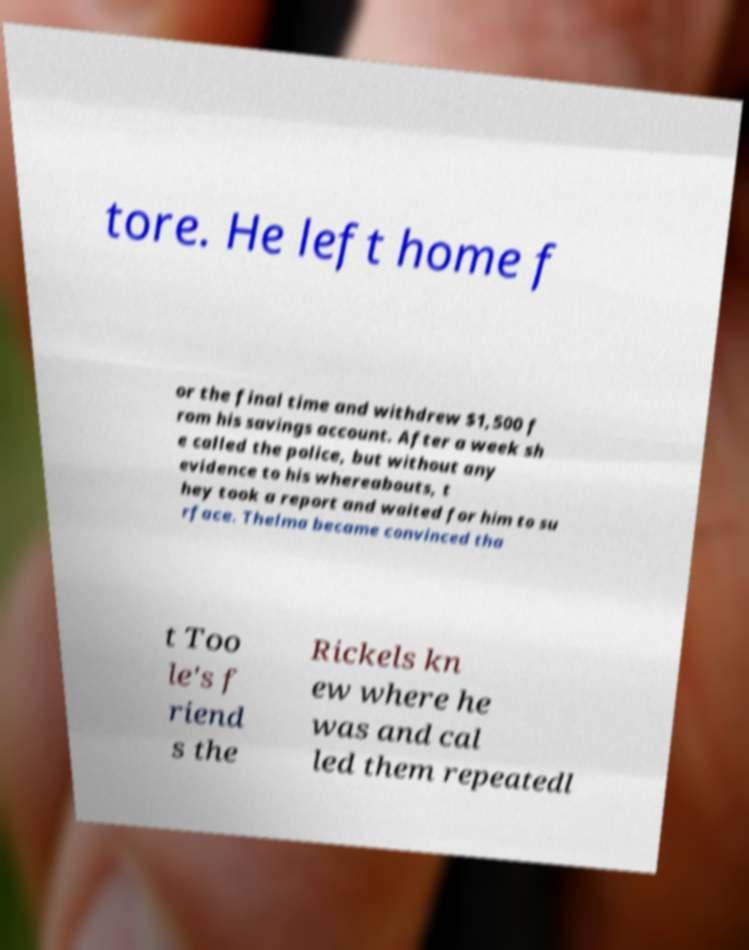Can you read and provide the text displayed in the image?This photo seems to have some interesting text. Can you extract and type it out for me? tore. He left home f or the final time and withdrew $1,500 f rom his savings account. After a week sh e called the police, but without any evidence to his whereabouts, t hey took a report and waited for him to su rface. Thelma became convinced tha t Too le's f riend s the Rickels kn ew where he was and cal led them repeatedl 